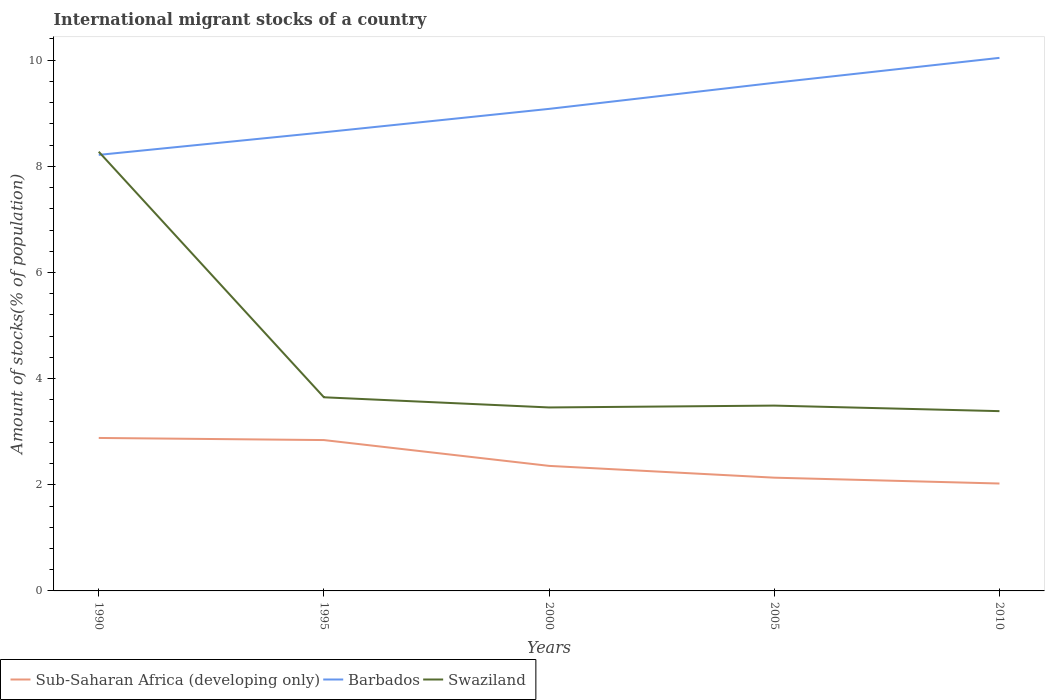How many different coloured lines are there?
Ensure brevity in your answer.  3. Does the line corresponding to Sub-Saharan Africa (developing only) intersect with the line corresponding to Swaziland?
Offer a terse response. No. Is the number of lines equal to the number of legend labels?
Provide a succinct answer. Yes. Across all years, what is the maximum amount of stocks in in Swaziland?
Make the answer very short. 3.39. In which year was the amount of stocks in in Barbados maximum?
Make the answer very short. 1990. What is the total amount of stocks in in Barbados in the graph?
Give a very brief answer. -0.96. What is the difference between the highest and the second highest amount of stocks in in Swaziland?
Ensure brevity in your answer.  4.89. How many years are there in the graph?
Keep it short and to the point. 5. Does the graph contain grids?
Offer a very short reply. No. Where does the legend appear in the graph?
Keep it short and to the point. Bottom left. How many legend labels are there?
Keep it short and to the point. 3. How are the legend labels stacked?
Provide a short and direct response. Horizontal. What is the title of the graph?
Your response must be concise. International migrant stocks of a country. What is the label or title of the X-axis?
Your response must be concise. Years. What is the label or title of the Y-axis?
Your response must be concise. Amount of stocks(% of population). What is the Amount of stocks(% of population) of Sub-Saharan Africa (developing only) in 1990?
Give a very brief answer. 2.88. What is the Amount of stocks(% of population) of Barbados in 1990?
Your response must be concise. 8.22. What is the Amount of stocks(% of population) of Swaziland in 1990?
Provide a succinct answer. 8.28. What is the Amount of stocks(% of population) of Sub-Saharan Africa (developing only) in 1995?
Offer a very short reply. 2.84. What is the Amount of stocks(% of population) in Barbados in 1995?
Provide a short and direct response. 8.64. What is the Amount of stocks(% of population) in Swaziland in 1995?
Make the answer very short. 3.65. What is the Amount of stocks(% of population) in Sub-Saharan Africa (developing only) in 2000?
Keep it short and to the point. 2.36. What is the Amount of stocks(% of population) of Barbados in 2000?
Ensure brevity in your answer.  9.08. What is the Amount of stocks(% of population) of Swaziland in 2000?
Make the answer very short. 3.46. What is the Amount of stocks(% of population) of Sub-Saharan Africa (developing only) in 2005?
Make the answer very short. 2.13. What is the Amount of stocks(% of population) of Barbados in 2005?
Offer a terse response. 9.57. What is the Amount of stocks(% of population) in Swaziland in 2005?
Provide a short and direct response. 3.49. What is the Amount of stocks(% of population) in Sub-Saharan Africa (developing only) in 2010?
Your answer should be very brief. 2.02. What is the Amount of stocks(% of population) in Barbados in 2010?
Ensure brevity in your answer.  10.04. What is the Amount of stocks(% of population) in Swaziland in 2010?
Keep it short and to the point. 3.39. Across all years, what is the maximum Amount of stocks(% of population) in Sub-Saharan Africa (developing only)?
Provide a short and direct response. 2.88. Across all years, what is the maximum Amount of stocks(% of population) of Barbados?
Your response must be concise. 10.04. Across all years, what is the maximum Amount of stocks(% of population) in Swaziland?
Provide a succinct answer. 8.28. Across all years, what is the minimum Amount of stocks(% of population) in Sub-Saharan Africa (developing only)?
Your answer should be very brief. 2.02. Across all years, what is the minimum Amount of stocks(% of population) in Barbados?
Your response must be concise. 8.22. Across all years, what is the minimum Amount of stocks(% of population) in Swaziland?
Your answer should be very brief. 3.39. What is the total Amount of stocks(% of population) of Sub-Saharan Africa (developing only) in the graph?
Provide a short and direct response. 12.24. What is the total Amount of stocks(% of population) in Barbados in the graph?
Offer a terse response. 45.56. What is the total Amount of stocks(% of population) in Swaziland in the graph?
Your answer should be compact. 22.26. What is the difference between the Amount of stocks(% of population) of Sub-Saharan Africa (developing only) in 1990 and that in 1995?
Your answer should be very brief. 0.04. What is the difference between the Amount of stocks(% of population) of Barbados in 1990 and that in 1995?
Ensure brevity in your answer.  -0.43. What is the difference between the Amount of stocks(% of population) of Swaziland in 1990 and that in 1995?
Your answer should be compact. 4.63. What is the difference between the Amount of stocks(% of population) in Sub-Saharan Africa (developing only) in 1990 and that in 2000?
Ensure brevity in your answer.  0.53. What is the difference between the Amount of stocks(% of population) of Barbados in 1990 and that in 2000?
Give a very brief answer. -0.87. What is the difference between the Amount of stocks(% of population) in Swaziland in 1990 and that in 2000?
Offer a very short reply. 4.82. What is the difference between the Amount of stocks(% of population) of Sub-Saharan Africa (developing only) in 1990 and that in 2005?
Offer a terse response. 0.75. What is the difference between the Amount of stocks(% of population) of Barbados in 1990 and that in 2005?
Your answer should be compact. -1.36. What is the difference between the Amount of stocks(% of population) of Swaziland in 1990 and that in 2005?
Your response must be concise. 4.78. What is the difference between the Amount of stocks(% of population) of Sub-Saharan Africa (developing only) in 1990 and that in 2010?
Your response must be concise. 0.86. What is the difference between the Amount of stocks(% of population) of Barbados in 1990 and that in 2010?
Your answer should be compact. -1.83. What is the difference between the Amount of stocks(% of population) in Swaziland in 1990 and that in 2010?
Ensure brevity in your answer.  4.89. What is the difference between the Amount of stocks(% of population) of Sub-Saharan Africa (developing only) in 1995 and that in 2000?
Provide a short and direct response. 0.49. What is the difference between the Amount of stocks(% of population) of Barbados in 1995 and that in 2000?
Offer a very short reply. -0.44. What is the difference between the Amount of stocks(% of population) of Swaziland in 1995 and that in 2000?
Give a very brief answer. 0.19. What is the difference between the Amount of stocks(% of population) of Sub-Saharan Africa (developing only) in 1995 and that in 2005?
Your answer should be very brief. 0.71. What is the difference between the Amount of stocks(% of population) of Barbados in 1995 and that in 2005?
Provide a short and direct response. -0.93. What is the difference between the Amount of stocks(% of population) of Swaziland in 1995 and that in 2005?
Make the answer very short. 0.16. What is the difference between the Amount of stocks(% of population) in Sub-Saharan Africa (developing only) in 1995 and that in 2010?
Provide a succinct answer. 0.82. What is the difference between the Amount of stocks(% of population) in Barbados in 1995 and that in 2010?
Keep it short and to the point. -1.4. What is the difference between the Amount of stocks(% of population) in Swaziland in 1995 and that in 2010?
Offer a terse response. 0.26. What is the difference between the Amount of stocks(% of population) of Sub-Saharan Africa (developing only) in 2000 and that in 2005?
Provide a short and direct response. 0.22. What is the difference between the Amount of stocks(% of population) in Barbados in 2000 and that in 2005?
Offer a terse response. -0.49. What is the difference between the Amount of stocks(% of population) in Swaziland in 2000 and that in 2005?
Your response must be concise. -0.04. What is the difference between the Amount of stocks(% of population) of Sub-Saharan Africa (developing only) in 2000 and that in 2010?
Provide a succinct answer. 0.33. What is the difference between the Amount of stocks(% of population) of Barbados in 2000 and that in 2010?
Your answer should be compact. -0.96. What is the difference between the Amount of stocks(% of population) of Swaziland in 2000 and that in 2010?
Give a very brief answer. 0.07. What is the difference between the Amount of stocks(% of population) of Sub-Saharan Africa (developing only) in 2005 and that in 2010?
Ensure brevity in your answer.  0.11. What is the difference between the Amount of stocks(% of population) of Barbados in 2005 and that in 2010?
Your response must be concise. -0.47. What is the difference between the Amount of stocks(% of population) of Swaziland in 2005 and that in 2010?
Your answer should be very brief. 0.1. What is the difference between the Amount of stocks(% of population) of Sub-Saharan Africa (developing only) in 1990 and the Amount of stocks(% of population) of Barbados in 1995?
Your response must be concise. -5.76. What is the difference between the Amount of stocks(% of population) in Sub-Saharan Africa (developing only) in 1990 and the Amount of stocks(% of population) in Swaziland in 1995?
Make the answer very short. -0.77. What is the difference between the Amount of stocks(% of population) in Barbados in 1990 and the Amount of stocks(% of population) in Swaziland in 1995?
Give a very brief answer. 4.57. What is the difference between the Amount of stocks(% of population) of Sub-Saharan Africa (developing only) in 1990 and the Amount of stocks(% of population) of Barbados in 2000?
Your answer should be very brief. -6.2. What is the difference between the Amount of stocks(% of population) of Sub-Saharan Africa (developing only) in 1990 and the Amount of stocks(% of population) of Swaziland in 2000?
Offer a very short reply. -0.57. What is the difference between the Amount of stocks(% of population) of Barbados in 1990 and the Amount of stocks(% of population) of Swaziland in 2000?
Ensure brevity in your answer.  4.76. What is the difference between the Amount of stocks(% of population) of Sub-Saharan Africa (developing only) in 1990 and the Amount of stocks(% of population) of Barbados in 2005?
Your answer should be compact. -6.69. What is the difference between the Amount of stocks(% of population) in Sub-Saharan Africa (developing only) in 1990 and the Amount of stocks(% of population) in Swaziland in 2005?
Provide a succinct answer. -0.61. What is the difference between the Amount of stocks(% of population) of Barbados in 1990 and the Amount of stocks(% of population) of Swaziland in 2005?
Keep it short and to the point. 4.72. What is the difference between the Amount of stocks(% of population) in Sub-Saharan Africa (developing only) in 1990 and the Amount of stocks(% of population) in Barbados in 2010?
Your answer should be very brief. -7.16. What is the difference between the Amount of stocks(% of population) in Sub-Saharan Africa (developing only) in 1990 and the Amount of stocks(% of population) in Swaziland in 2010?
Your answer should be very brief. -0.51. What is the difference between the Amount of stocks(% of population) in Barbados in 1990 and the Amount of stocks(% of population) in Swaziland in 2010?
Provide a short and direct response. 4.83. What is the difference between the Amount of stocks(% of population) of Sub-Saharan Africa (developing only) in 1995 and the Amount of stocks(% of population) of Barbados in 2000?
Your answer should be compact. -6.24. What is the difference between the Amount of stocks(% of population) of Sub-Saharan Africa (developing only) in 1995 and the Amount of stocks(% of population) of Swaziland in 2000?
Your response must be concise. -0.61. What is the difference between the Amount of stocks(% of population) in Barbados in 1995 and the Amount of stocks(% of population) in Swaziland in 2000?
Your answer should be very brief. 5.18. What is the difference between the Amount of stocks(% of population) of Sub-Saharan Africa (developing only) in 1995 and the Amount of stocks(% of population) of Barbados in 2005?
Offer a terse response. -6.73. What is the difference between the Amount of stocks(% of population) in Sub-Saharan Africa (developing only) in 1995 and the Amount of stocks(% of population) in Swaziland in 2005?
Provide a short and direct response. -0.65. What is the difference between the Amount of stocks(% of population) in Barbados in 1995 and the Amount of stocks(% of population) in Swaziland in 2005?
Give a very brief answer. 5.15. What is the difference between the Amount of stocks(% of population) of Sub-Saharan Africa (developing only) in 1995 and the Amount of stocks(% of population) of Barbados in 2010?
Provide a short and direct response. -7.2. What is the difference between the Amount of stocks(% of population) in Sub-Saharan Africa (developing only) in 1995 and the Amount of stocks(% of population) in Swaziland in 2010?
Your answer should be very brief. -0.55. What is the difference between the Amount of stocks(% of population) in Barbados in 1995 and the Amount of stocks(% of population) in Swaziland in 2010?
Your response must be concise. 5.25. What is the difference between the Amount of stocks(% of population) of Sub-Saharan Africa (developing only) in 2000 and the Amount of stocks(% of population) of Barbados in 2005?
Make the answer very short. -7.22. What is the difference between the Amount of stocks(% of population) of Sub-Saharan Africa (developing only) in 2000 and the Amount of stocks(% of population) of Swaziland in 2005?
Your answer should be very brief. -1.14. What is the difference between the Amount of stocks(% of population) of Barbados in 2000 and the Amount of stocks(% of population) of Swaziland in 2005?
Provide a succinct answer. 5.59. What is the difference between the Amount of stocks(% of population) in Sub-Saharan Africa (developing only) in 2000 and the Amount of stocks(% of population) in Barbados in 2010?
Provide a succinct answer. -7.69. What is the difference between the Amount of stocks(% of population) in Sub-Saharan Africa (developing only) in 2000 and the Amount of stocks(% of population) in Swaziland in 2010?
Offer a very short reply. -1.03. What is the difference between the Amount of stocks(% of population) in Barbados in 2000 and the Amount of stocks(% of population) in Swaziland in 2010?
Keep it short and to the point. 5.7. What is the difference between the Amount of stocks(% of population) in Sub-Saharan Africa (developing only) in 2005 and the Amount of stocks(% of population) in Barbados in 2010?
Give a very brief answer. -7.91. What is the difference between the Amount of stocks(% of population) of Sub-Saharan Africa (developing only) in 2005 and the Amount of stocks(% of population) of Swaziland in 2010?
Provide a short and direct response. -1.25. What is the difference between the Amount of stocks(% of population) of Barbados in 2005 and the Amount of stocks(% of population) of Swaziland in 2010?
Offer a very short reply. 6.19. What is the average Amount of stocks(% of population) of Sub-Saharan Africa (developing only) per year?
Offer a very short reply. 2.45. What is the average Amount of stocks(% of population) of Barbados per year?
Give a very brief answer. 9.11. What is the average Amount of stocks(% of population) of Swaziland per year?
Give a very brief answer. 4.45. In the year 1990, what is the difference between the Amount of stocks(% of population) in Sub-Saharan Africa (developing only) and Amount of stocks(% of population) in Barbados?
Offer a terse response. -5.33. In the year 1990, what is the difference between the Amount of stocks(% of population) of Sub-Saharan Africa (developing only) and Amount of stocks(% of population) of Swaziland?
Ensure brevity in your answer.  -5.39. In the year 1990, what is the difference between the Amount of stocks(% of population) in Barbados and Amount of stocks(% of population) in Swaziland?
Provide a succinct answer. -0.06. In the year 1995, what is the difference between the Amount of stocks(% of population) of Sub-Saharan Africa (developing only) and Amount of stocks(% of population) of Barbados?
Keep it short and to the point. -5.8. In the year 1995, what is the difference between the Amount of stocks(% of population) in Sub-Saharan Africa (developing only) and Amount of stocks(% of population) in Swaziland?
Your answer should be compact. -0.81. In the year 1995, what is the difference between the Amount of stocks(% of population) in Barbados and Amount of stocks(% of population) in Swaziland?
Give a very brief answer. 4.99. In the year 2000, what is the difference between the Amount of stocks(% of population) of Sub-Saharan Africa (developing only) and Amount of stocks(% of population) of Barbados?
Offer a very short reply. -6.73. In the year 2000, what is the difference between the Amount of stocks(% of population) in Sub-Saharan Africa (developing only) and Amount of stocks(% of population) in Swaziland?
Make the answer very short. -1.1. In the year 2000, what is the difference between the Amount of stocks(% of population) in Barbados and Amount of stocks(% of population) in Swaziland?
Your answer should be compact. 5.63. In the year 2005, what is the difference between the Amount of stocks(% of population) of Sub-Saharan Africa (developing only) and Amount of stocks(% of population) of Barbados?
Keep it short and to the point. -7.44. In the year 2005, what is the difference between the Amount of stocks(% of population) in Sub-Saharan Africa (developing only) and Amount of stocks(% of population) in Swaziland?
Offer a terse response. -1.36. In the year 2005, what is the difference between the Amount of stocks(% of population) in Barbados and Amount of stocks(% of population) in Swaziland?
Your response must be concise. 6.08. In the year 2010, what is the difference between the Amount of stocks(% of population) in Sub-Saharan Africa (developing only) and Amount of stocks(% of population) in Barbados?
Your answer should be compact. -8.02. In the year 2010, what is the difference between the Amount of stocks(% of population) in Sub-Saharan Africa (developing only) and Amount of stocks(% of population) in Swaziland?
Keep it short and to the point. -1.36. In the year 2010, what is the difference between the Amount of stocks(% of population) of Barbados and Amount of stocks(% of population) of Swaziland?
Your answer should be compact. 6.66. What is the ratio of the Amount of stocks(% of population) in Barbados in 1990 to that in 1995?
Your response must be concise. 0.95. What is the ratio of the Amount of stocks(% of population) in Swaziland in 1990 to that in 1995?
Give a very brief answer. 2.27. What is the ratio of the Amount of stocks(% of population) of Sub-Saharan Africa (developing only) in 1990 to that in 2000?
Make the answer very short. 1.22. What is the ratio of the Amount of stocks(% of population) of Barbados in 1990 to that in 2000?
Give a very brief answer. 0.9. What is the ratio of the Amount of stocks(% of population) in Swaziland in 1990 to that in 2000?
Provide a succinct answer. 2.39. What is the ratio of the Amount of stocks(% of population) in Sub-Saharan Africa (developing only) in 1990 to that in 2005?
Provide a short and direct response. 1.35. What is the ratio of the Amount of stocks(% of population) of Barbados in 1990 to that in 2005?
Provide a succinct answer. 0.86. What is the ratio of the Amount of stocks(% of population) of Swaziland in 1990 to that in 2005?
Offer a terse response. 2.37. What is the ratio of the Amount of stocks(% of population) in Sub-Saharan Africa (developing only) in 1990 to that in 2010?
Provide a short and direct response. 1.42. What is the ratio of the Amount of stocks(% of population) in Barbados in 1990 to that in 2010?
Your response must be concise. 0.82. What is the ratio of the Amount of stocks(% of population) of Swaziland in 1990 to that in 2010?
Provide a short and direct response. 2.44. What is the ratio of the Amount of stocks(% of population) of Sub-Saharan Africa (developing only) in 1995 to that in 2000?
Provide a short and direct response. 1.21. What is the ratio of the Amount of stocks(% of population) in Barbados in 1995 to that in 2000?
Make the answer very short. 0.95. What is the ratio of the Amount of stocks(% of population) in Swaziland in 1995 to that in 2000?
Make the answer very short. 1.06. What is the ratio of the Amount of stocks(% of population) of Sub-Saharan Africa (developing only) in 1995 to that in 2005?
Offer a terse response. 1.33. What is the ratio of the Amount of stocks(% of population) of Barbados in 1995 to that in 2005?
Make the answer very short. 0.9. What is the ratio of the Amount of stocks(% of population) in Swaziland in 1995 to that in 2005?
Give a very brief answer. 1.04. What is the ratio of the Amount of stocks(% of population) of Sub-Saharan Africa (developing only) in 1995 to that in 2010?
Ensure brevity in your answer.  1.4. What is the ratio of the Amount of stocks(% of population) in Barbados in 1995 to that in 2010?
Ensure brevity in your answer.  0.86. What is the ratio of the Amount of stocks(% of population) in Swaziland in 1995 to that in 2010?
Provide a succinct answer. 1.08. What is the ratio of the Amount of stocks(% of population) of Sub-Saharan Africa (developing only) in 2000 to that in 2005?
Your response must be concise. 1.1. What is the ratio of the Amount of stocks(% of population) in Barbados in 2000 to that in 2005?
Ensure brevity in your answer.  0.95. What is the ratio of the Amount of stocks(% of population) in Sub-Saharan Africa (developing only) in 2000 to that in 2010?
Provide a short and direct response. 1.16. What is the ratio of the Amount of stocks(% of population) in Barbados in 2000 to that in 2010?
Offer a very short reply. 0.9. What is the ratio of the Amount of stocks(% of population) of Swaziland in 2000 to that in 2010?
Ensure brevity in your answer.  1.02. What is the ratio of the Amount of stocks(% of population) of Sub-Saharan Africa (developing only) in 2005 to that in 2010?
Your answer should be compact. 1.05. What is the ratio of the Amount of stocks(% of population) of Barbados in 2005 to that in 2010?
Provide a short and direct response. 0.95. What is the ratio of the Amount of stocks(% of population) of Swaziland in 2005 to that in 2010?
Offer a terse response. 1.03. What is the difference between the highest and the second highest Amount of stocks(% of population) in Sub-Saharan Africa (developing only)?
Offer a terse response. 0.04. What is the difference between the highest and the second highest Amount of stocks(% of population) in Barbados?
Provide a succinct answer. 0.47. What is the difference between the highest and the second highest Amount of stocks(% of population) in Swaziland?
Give a very brief answer. 4.63. What is the difference between the highest and the lowest Amount of stocks(% of population) of Sub-Saharan Africa (developing only)?
Keep it short and to the point. 0.86. What is the difference between the highest and the lowest Amount of stocks(% of population) in Barbados?
Provide a succinct answer. 1.83. What is the difference between the highest and the lowest Amount of stocks(% of population) in Swaziland?
Your response must be concise. 4.89. 